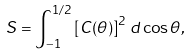Convert formula to latex. <formula><loc_0><loc_0><loc_500><loc_500>S = \int _ { - 1 } ^ { 1 / 2 } \left [ C ( \theta ) \right ] ^ { 2 } \, d \cos \theta ,</formula> 